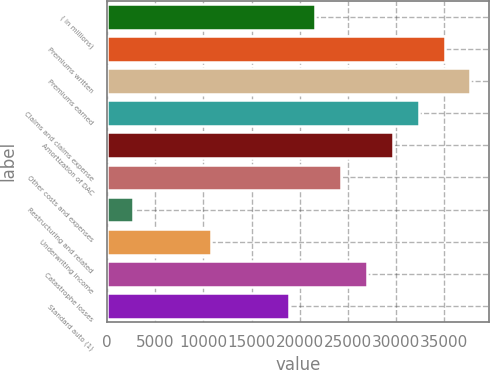<chart> <loc_0><loc_0><loc_500><loc_500><bar_chart><fcel>( in millions)<fcel>Premiums written<fcel>Premiums earned<fcel>Claims and claims expense<fcel>Amortization of DAC<fcel>Other costs and expenses<fcel>Restructuring and related<fcel>Underwriting income<fcel>Catastrophe losses<fcel>Standard auto (1)<nl><fcel>21577.4<fcel>35051.4<fcel>37746.2<fcel>32356.6<fcel>29661.8<fcel>24272.2<fcel>2713.8<fcel>10798.2<fcel>26967<fcel>18882.6<nl></chart> 